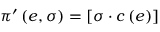Convert formula to latex. <formula><loc_0><loc_0><loc_500><loc_500>\pi ^ { \prime } \left ( e , \sigma \right ) = \left [ \sigma \cdot c \left ( e \right ) \right ]</formula> 